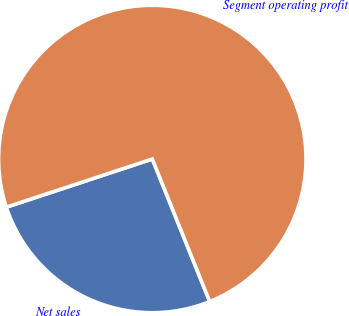<chart> <loc_0><loc_0><loc_500><loc_500><pie_chart><fcel>Net sales<fcel>Segment operating profit<nl><fcel>26.02%<fcel>73.98%<nl></chart> 